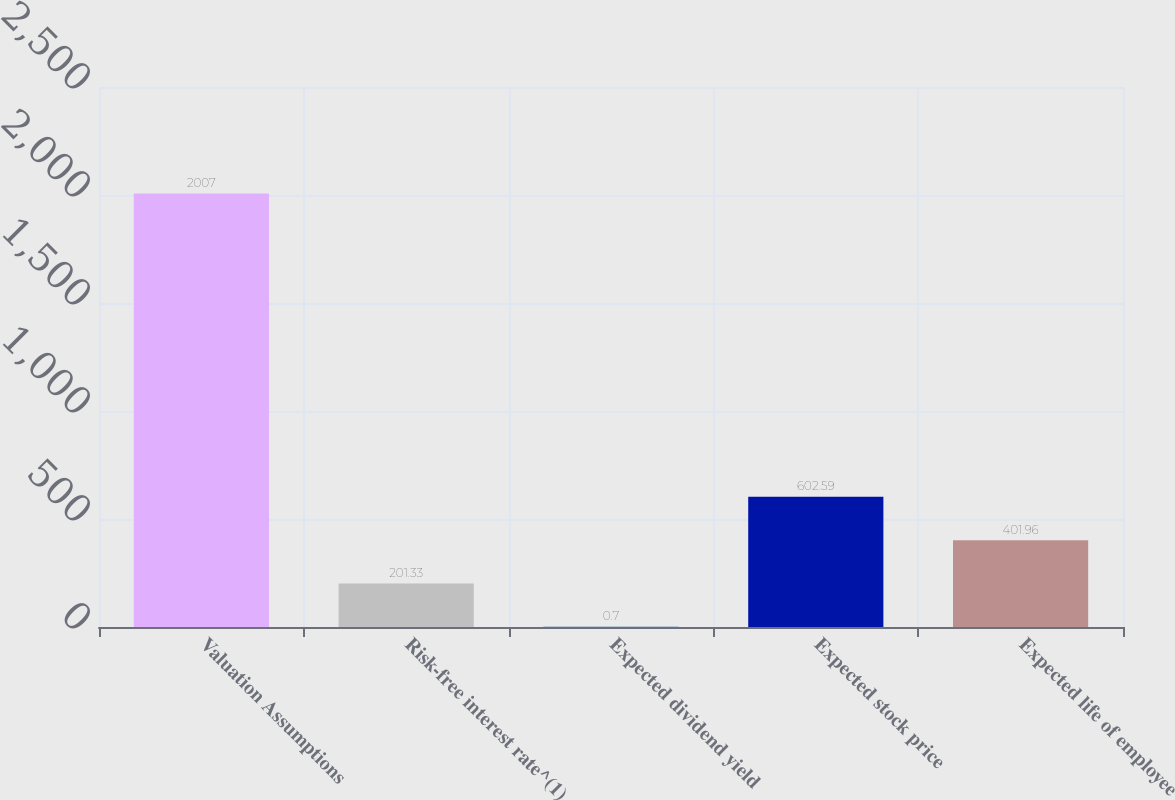Convert chart. <chart><loc_0><loc_0><loc_500><loc_500><bar_chart><fcel>Valuation Assumptions<fcel>Risk-free interest rate^(1)<fcel>Expected dividend yield<fcel>Expected stock price<fcel>Expected life of employee<nl><fcel>2007<fcel>201.33<fcel>0.7<fcel>602.59<fcel>401.96<nl></chart> 